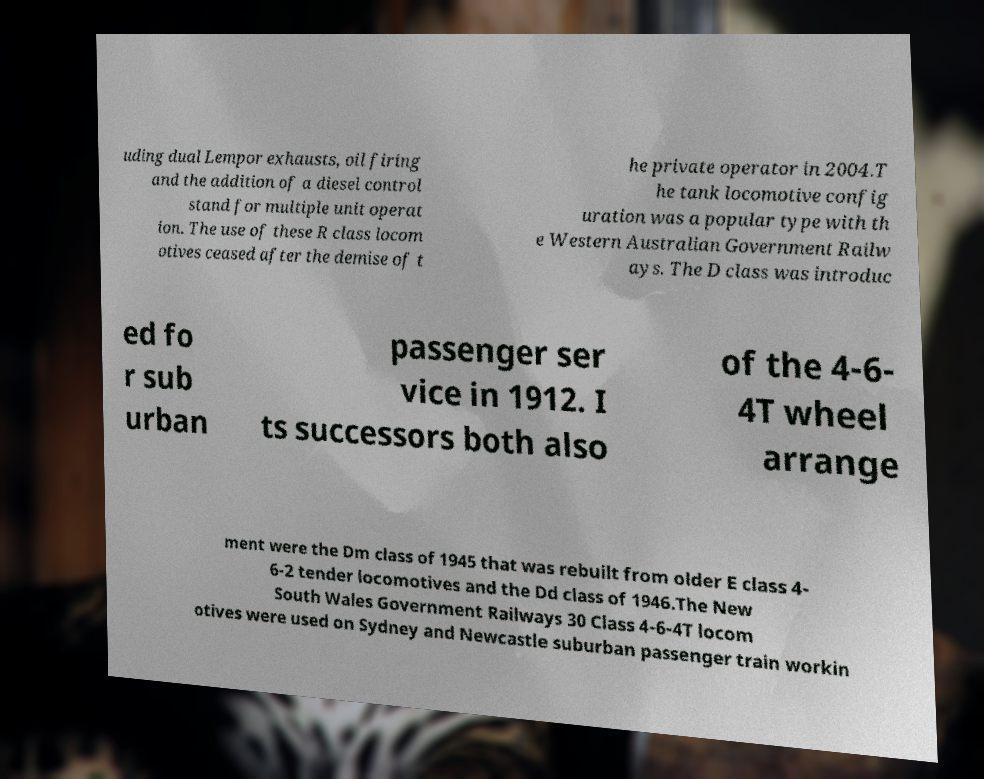Please identify and transcribe the text found in this image. uding dual Lempor exhausts, oil firing and the addition of a diesel control stand for multiple unit operat ion. The use of these R class locom otives ceased after the demise of t he private operator in 2004.T he tank locomotive config uration was a popular type with th e Western Australian Government Railw ays. The D class was introduc ed fo r sub urban passenger ser vice in 1912. I ts successors both also of the 4-6- 4T wheel arrange ment were the Dm class of 1945 that was rebuilt from older E class 4- 6-2 tender locomotives and the Dd class of 1946.The New South Wales Government Railways 30 Class 4-6-4T locom otives were used on Sydney and Newcastle suburban passenger train workin 